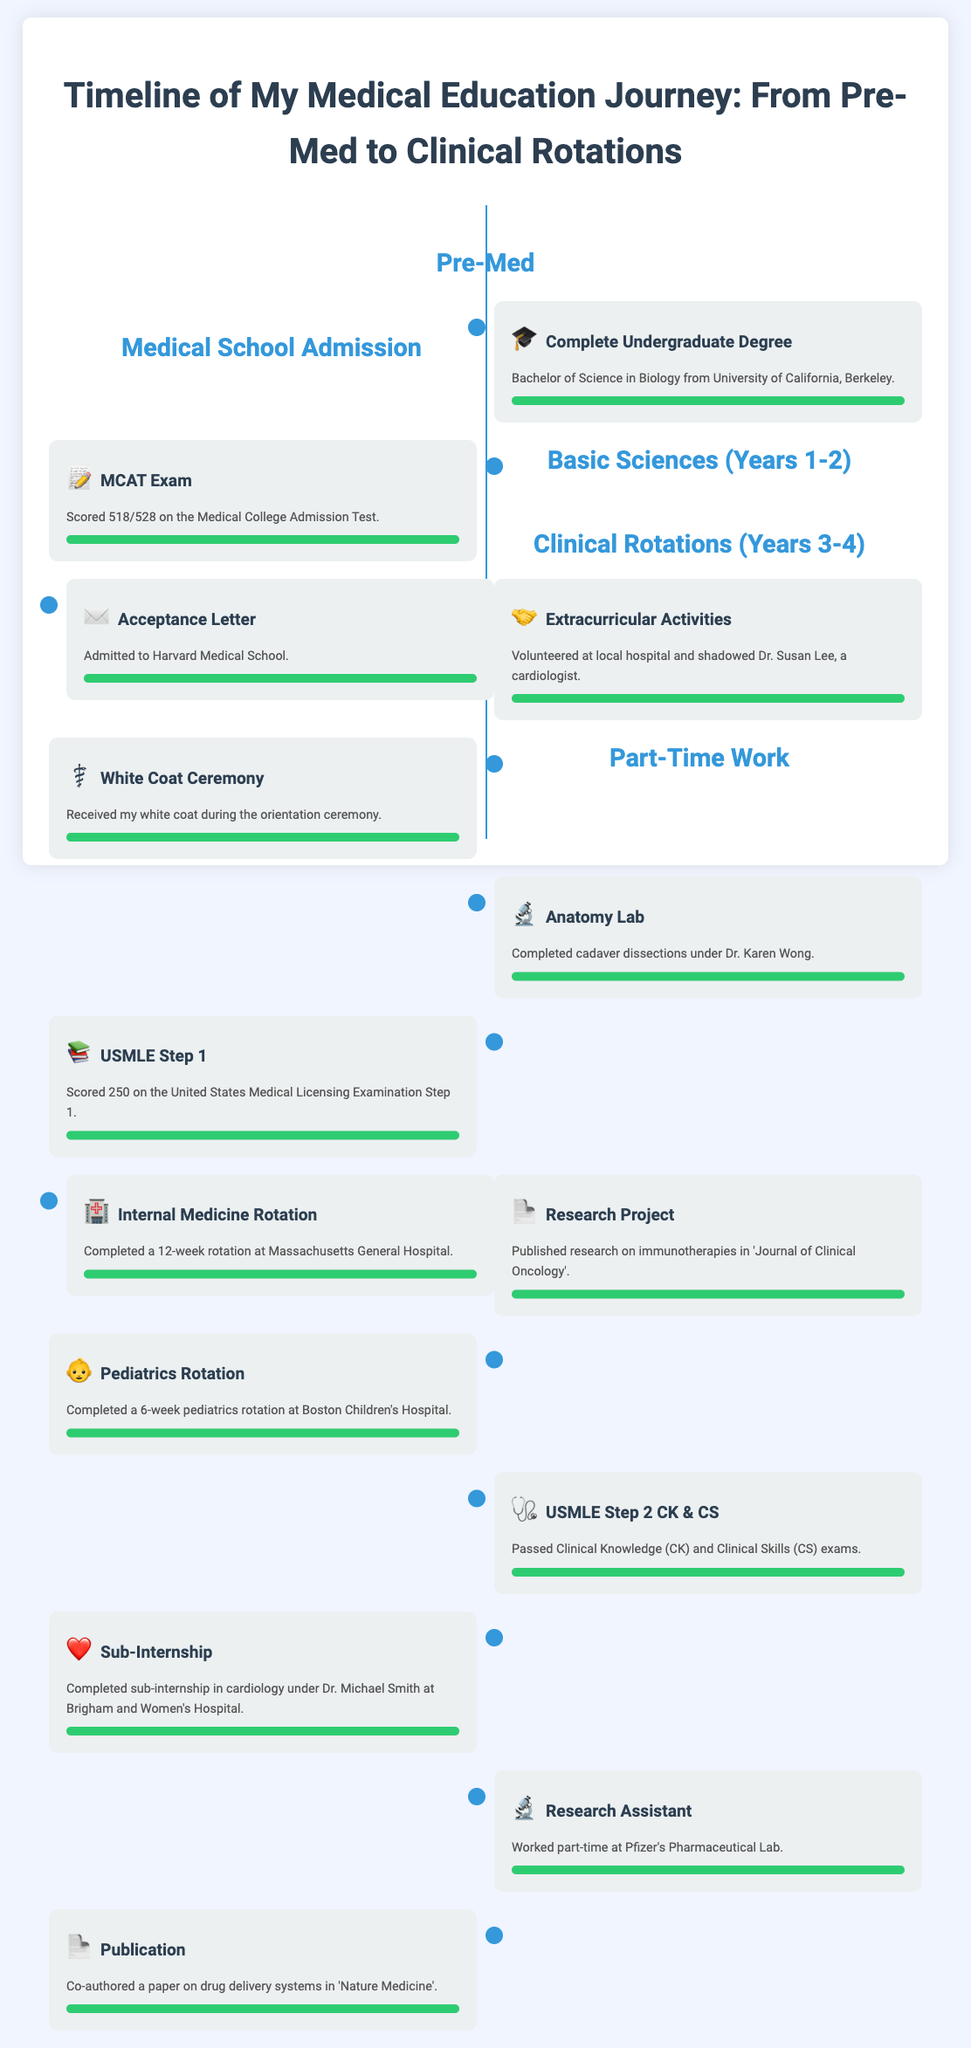What degree was completed? The document states that a Bachelor of Science in Biology was completed from the University of California, Berkeley.
Answer: Bachelor of Science in Biology What was the MCAT score? The MCAT score mentioned in the document is 518 out of 528.
Answer: 518/528 Which medical school was attended? The document indicates that the individual was admitted to Harvard Medical School.
Answer: Harvard Medical School What is the title of the research project published? The document states that the research on immunotherapies was published in the 'Journal of Clinical Oncology'.
Answer: Journal of Clinical Oncology How long was the Internal Medicine rotation? The document specifies that the Internal Medicine rotation lasted 12 weeks.
Answer: 12 weeks Who supervised the anatomy lab? According to the document, the anatomy lab was completed under Dr. Karen Wong.
Answer: Dr. Karen Wong Which hospital was the pediatrics rotation completed at? The document mentions the pediatrics rotation was completed at Boston Children's Hospital.
Answer: Boston Children's Hospital What type of work did the individual do part-time? The individual worked as a Research Assistant in a pharmaceutical lab.
Answer: Research Assistant What was co-authored in 'Nature Medicine'? The document indicates a paper on drug delivery systems was co-authored.
Answer: Paper on drug delivery systems 